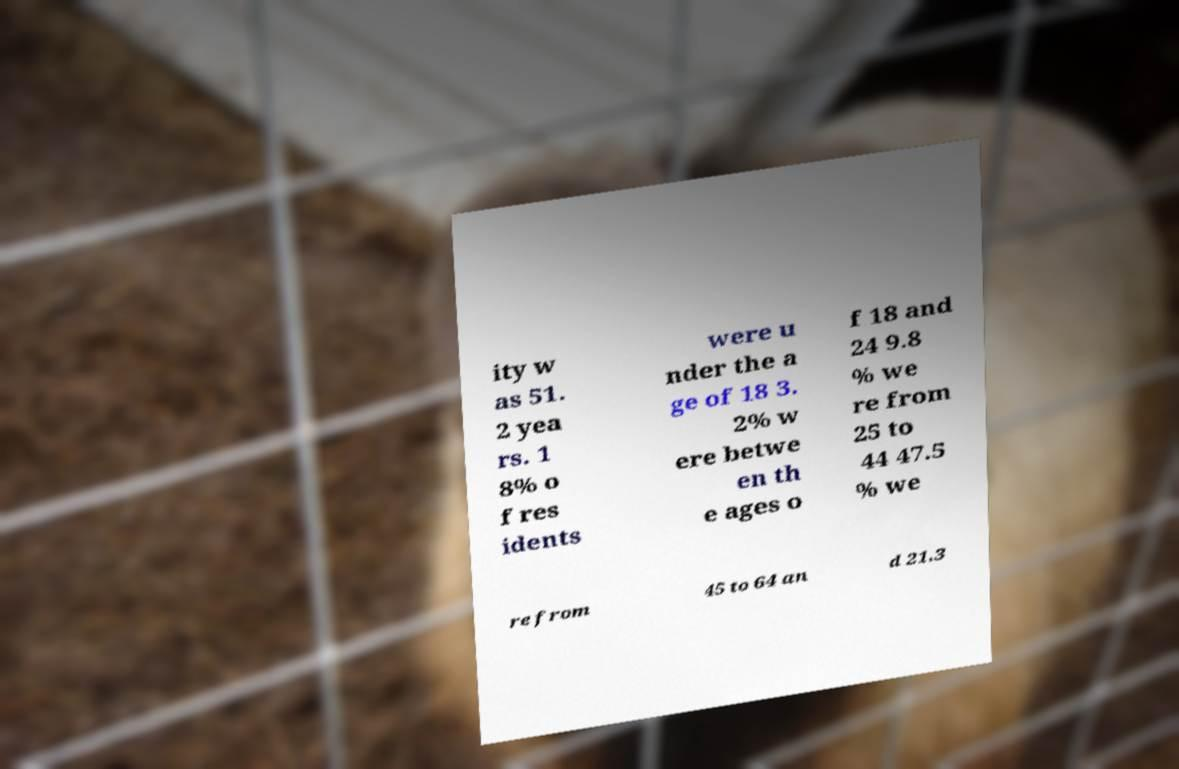Can you accurately transcribe the text from the provided image for me? ity w as 51. 2 yea rs. 1 8% o f res idents were u nder the a ge of 18 3. 2% w ere betwe en th e ages o f 18 and 24 9.8 % we re from 25 to 44 47.5 % we re from 45 to 64 an d 21.3 